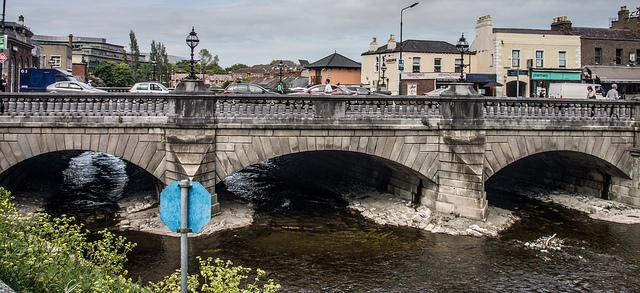What kind of river channel it is? large 